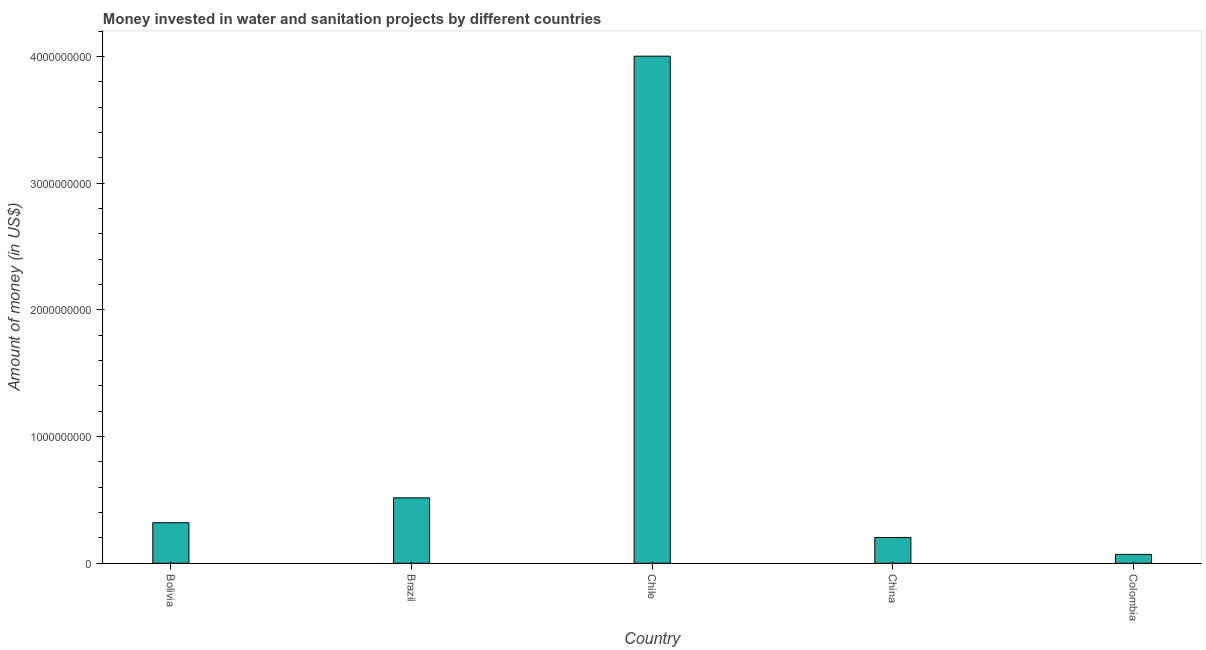What is the title of the graph?
Keep it short and to the point. Money invested in water and sanitation projects by different countries. What is the label or title of the Y-axis?
Provide a short and direct response. Amount of money (in US$). What is the investment in Bolivia?
Provide a short and direct response. 3.20e+08. Across all countries, what is the maximum investment?
Ensure brevity in your answer.  4.00e+09. Across all countries, what is the minimum investment?
Your answer should be compact. 7.00e+07. In which country was the investment maximum?
Provide a short and direct response. Chile. What is the sum of the investment?
Give a very brief answer. 5.11e+09. What is the difference between the investment in Brazil and China?
Make the answer very short. 3.13e+08. What is the average investment per country?
Offer a terse response. 1.02e+09. What is the median investment?
Your response must be concise. 3.20e+08. In how many countries, is the investment greater than 400000000 US$?
Your answer should be very brief. 2. What is the ratio of the investment in Bolivia to that in Colombia?
Provide a short and direct response. 4.57. Is the investment in Brazil less than that in Colombia?
Your answer should be compact. No. What is the difference between the highest and the second highest investment?
Offer a very short reply. 3.49e+09. What is the difference between the highest and the lowest investment?
Your answer should be very brief. 3.93e+09. In how many countries, is the investment greater than the average investment taken over all countries?
Your response must be concise. 1. What is the difference between two consecutive major ticks on the Y-axis?
Make the answer very short. 1.00e+09. What is the Amount of money (in US$) in Bolivia?
Provide a short and direct response. 3.20e+08. What is the Amount of money (in US$) in Brazil?
Your answer should be very brief. 5.16e+08. What is the Amount of money (in US$) in Chile?
Provide a short and direct response. 4.00e+09. What is the Amount of money (in US$) in China?
Ensure brevity in your answer.  2.03e+08. What is the Amount of money (in US$) in Colombia?
Offer a terse response. 7.00e+07. What is the difference between the Amount of money (in US$) in Bolivia and Brazil?
Provide a short and direct response. -1.96e+08. What is the difference between the Amount of money (in US$) in Bolivia and Chile?
Keep it short and to the point. -3.68e+09. What is the difference between the Amount of money (in US$) in Bolivia and China?
Ensure brevity in your answer.  1.17e+08. What is the difference between the Amount of money (in US$) in Bolivia and Colombia?
Keep it short and to the point. 2.50e+08. What is the difference between the Amount of money (in US$) in Brazil and Chile?
Provide a succinct answer. -3.49e+09. What is the difference between the Amount of money (in US$) in Brazil and China?
Keep it short and to the point. 3.13e+08. What is the difference between the Amount of money (in US$) in Brazil and Colombia?
Provide a short and direct response. 4.46e+08. What is the difference between the Amount of money (in US$) in Chile and China?
Provide a succinct answer. 3.80e+09. What is the difference between the Amount of money (in US$) in Chile and Colombia?
Offer a very short reply. 3.93e+09. What is the difference between the Amount of money (in US$) in China and Colombia?
Your answer should be very brief. 1.33e+08. What is the ratio of the Amount of money (in US$) in Bolivia to that in Brazil?
Offer a very short reply. 0.62. What is the ratio of the Amount of money (in US$) in Bolivia to that in Chile?
Make the answer very short. 0.08. What is the ratio of the Amount of money (in US$) in Bolivia to that in China?
Ensure brevity in your answer.  1.57. What is the ratio of the Amount of money (in US$) in Bolivia to that in Colombia?
Keep it short and to the point. 4.57. What is the ratio of the Amount of money (in US$) in Brazil to that in Chile?
Keep it short and to the point. 0.13. What is the ratio of the Amount of money (in US$) in Brazil to that in China?
Offer a very short reply. 2.54. What is the ratio of the Amount of money (in US$) in Brazil to that in Colombia?
Ensure brevity in your answer.  7.38. What is the ratio of the Amount of money (in US$) in Chile to that in China?
Give a very brief answer. 19.7. What is the ratio of the Amount of money (in US$) in Chile to that in Colombia?
Your answer should be compact. 57.19. What is the ratio of the Amount of money (in US$) in China to that in Colombia?
Give a very brief answer. 2.9. 